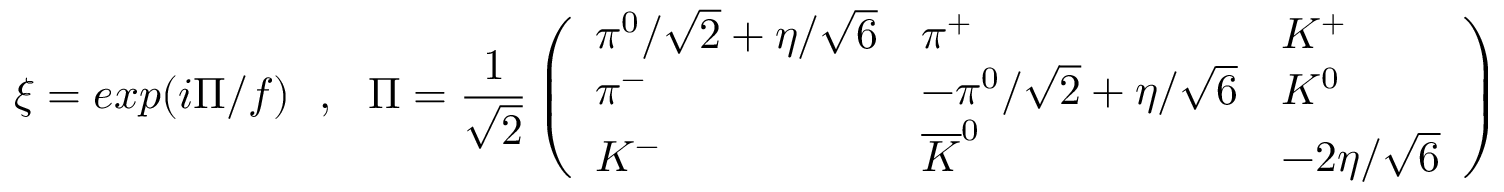Convert formula to latex. <formula><loc_0><loc_0><loc_500><loc_500>\xi = e x p ( i \Pi / f ) \quad , \quad P i = \frac { 1 } { \sqrt { 2 } } \left ( \begin{array} { l l l } { { \pi ^ { 0 } / \sqrt { 2 } + \eta / \sqrt { 6 } } } & { { \pi ^ { + } } } & { { K ^ { + } } } \\ { { \pi ^ { - } } } & { { - \pi ^ { 0 } / \sqrt { 2 } + \eta / \sqrt { 6 } } } & { { K ^ { 0 } } } \\ { { K ^ { - } } } & { { \overline { K } ^ { 0 } } } & { { - 2 \eta / \sqrt { 6 } } } \end{array} \right ) \quad .</formula> 